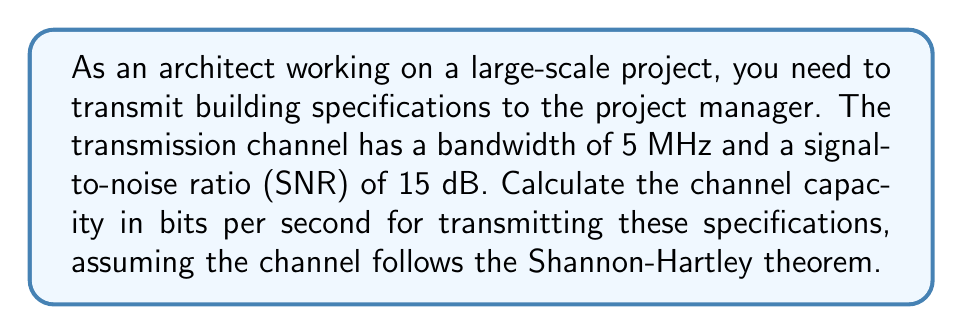Teach me how to tackle this problem. To solve this problem, we'll use the Shannon-Hartley theorem, which gives the channel capacity for a noisy communication channel. The theorem states:

$$C = B \log_2(1 + SNR)$$

Where:
$C$ = Channel capacity (bits per second)
$B$ = Bandwidth (Hz)
$SNR$ = Signal-to-Noise Ratio (linear scale)

Given:
- Bandwidth $(B) = 5$ MHz $= 5 \times 10^6$ Hz
- SNR = 15 dB

Step 1: Convert SNR from dB to linear scale
SNR in dB = $10 \log_{10}(SNR)$
$15 = 10 \log_{10}(SNR)$
$1.5 = \log_{10}(SNR)$
$SNR = 10^{1.5} \approx 31.6228$

Step 2: Apply the Shannon-Hartley theorem
$$\begin{align*}
C &= B \log_2(1 + SNR) \\
&= (5 \times 10^6) \log_2(1 + 31.6228) \\
&= (5 \times 10^6) \log_2(32.6228) \\
&= (5 \times 10^6) (5.0279) \\
&= 25,139,500 \text{ bits per second}
\end{align*}$$

Step 3: Convert to Mbps for easier interpretation
$25,139,500 \text{ bps} = 25.1395 \text{ Mbps}$
Answer: The channel capacity for transmitting building specifications is approximately 25.1395 Mbps (megabits per second). 